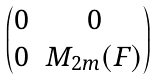<formula> <loc_0><loc_0><loc_500><loc_500>\begin{pmatrix} 0 & 0 \\ 0 & M _ { 2 m } ( F ) \end{pmatrix}</formula> 